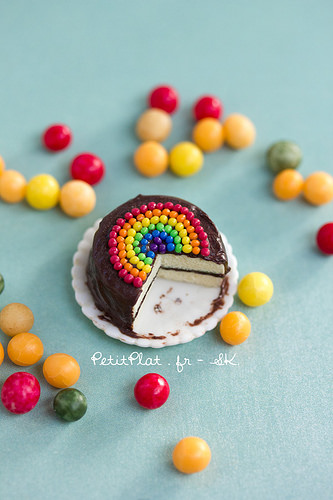<image>
Is the cake under the sweet? Yes. The cake is positioned underneath the sweet, with the sweet above it in the vertical space. Where is the cake in relation to the plate? Is it on the plate? Yes. Looking at the image, I can see the cake is positioned on top of the plate, with the plate providing support. 